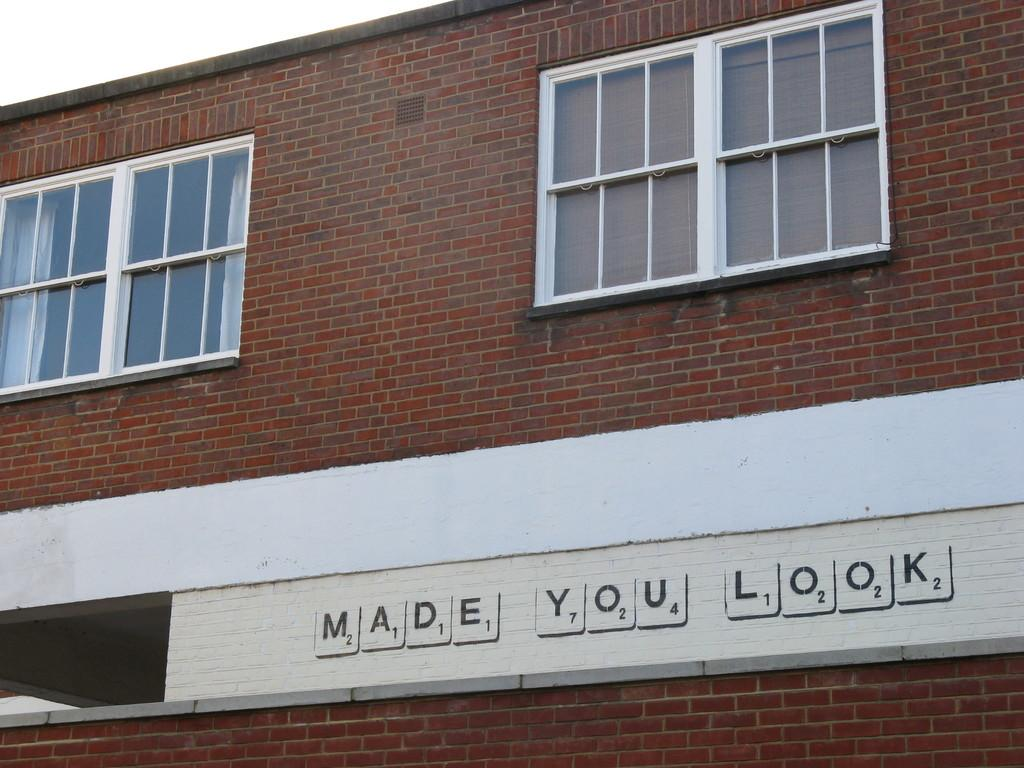What is the main subject of the picture? The main subject of the picture is a building. What can be seen on the wall of the building? There is text on the wall of the building. How would you describe the sky in the picture? The sky is cloudy in the picture. Who is the owner of the duck in the picture? There is no duck present in the image, so it is not possible to determine the owner. 